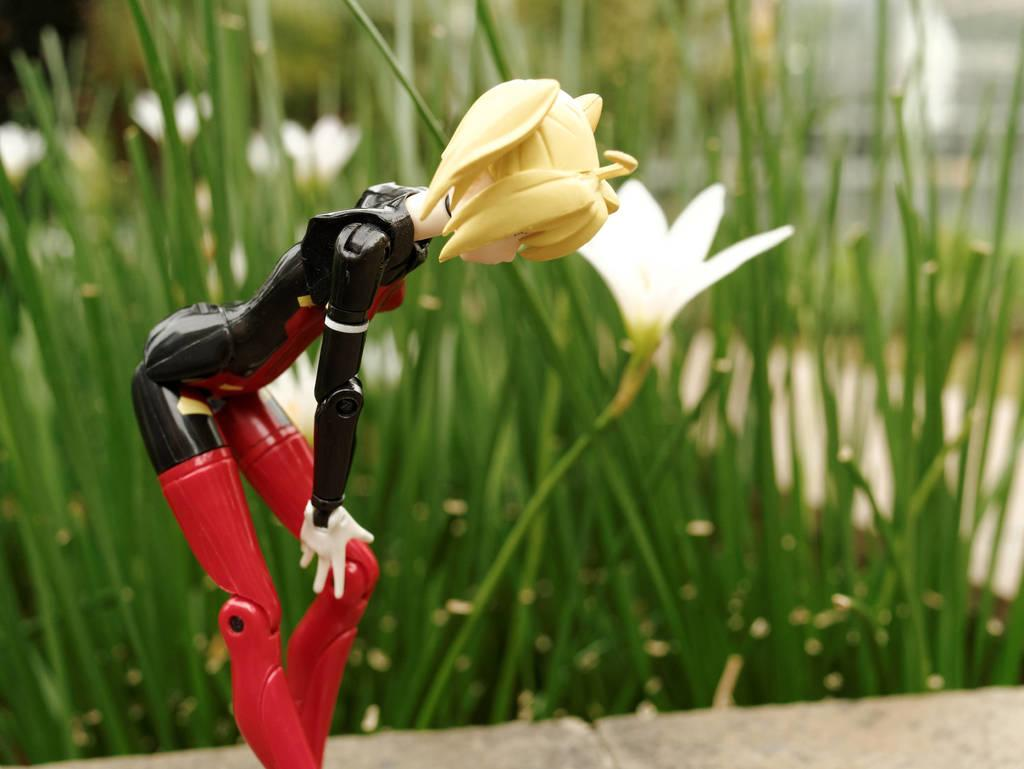What is the main object in the foreground of the image? There is a toy in the foreground of the image. What can be seen in the background of the image? There are plants and flowers in the background of the image. What type of path is visible at the bottom of the image? There is a walkway at the bottom of the image. What line can be seen connecting the toy to the flowers in the image? There is no line connecting the toy to the flowers in the image. How does the digestion of the toy affect the plants in the image? The toy is not a living organism and therefore cannot have a digestive system or affect the plants in the image. 